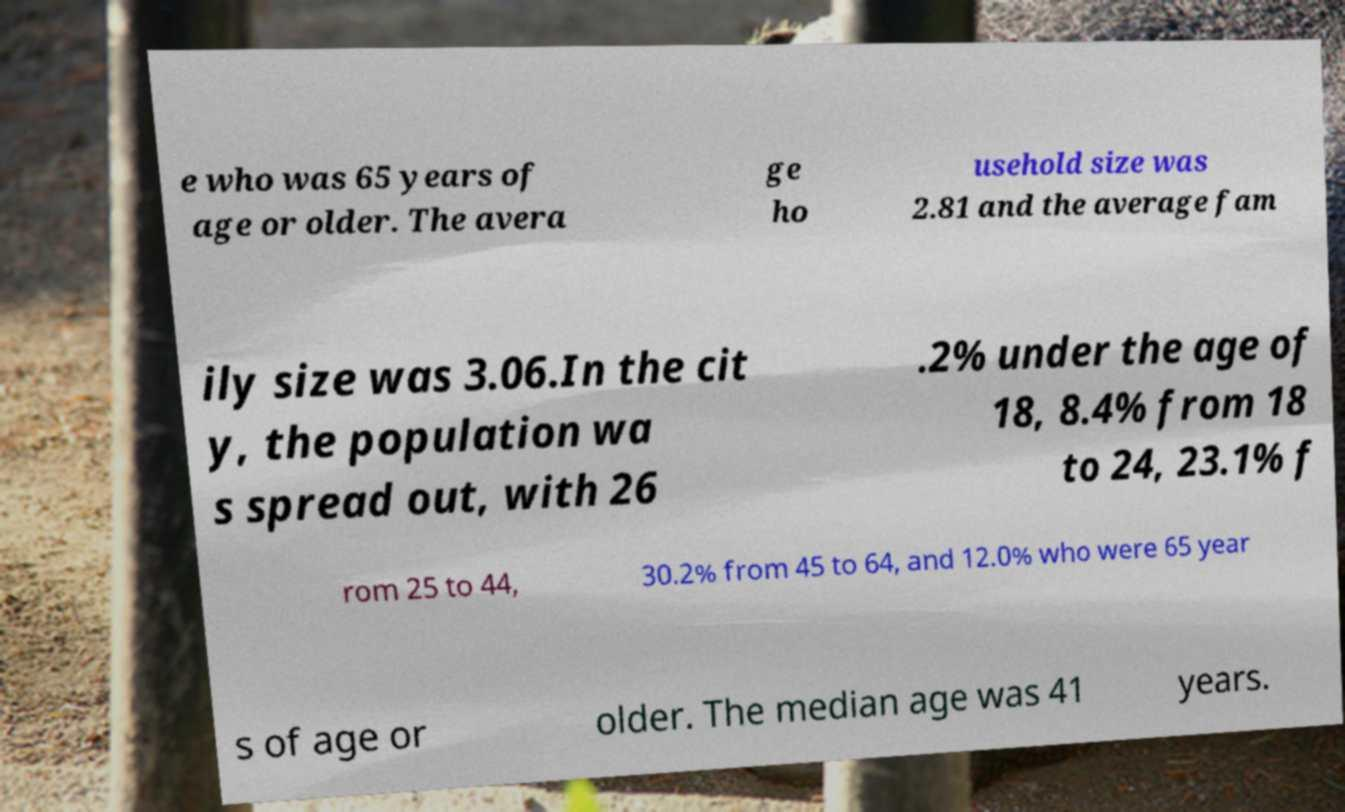Can you accurately transcribe the text from the provided image for me? e who was 65 years of age or older. The avera ge ho usehold size was 2.81 and the average fam ily size was 3.06.In the cit y, the population wa s spread out, with 26 .2% under the age of 18, 8.4% from 18 to 24, 23.1% f rom 25 to 44, 30.2% from 45 to 64, and 12.0% who were 65 year s of age or older. The median age was 41 years. 